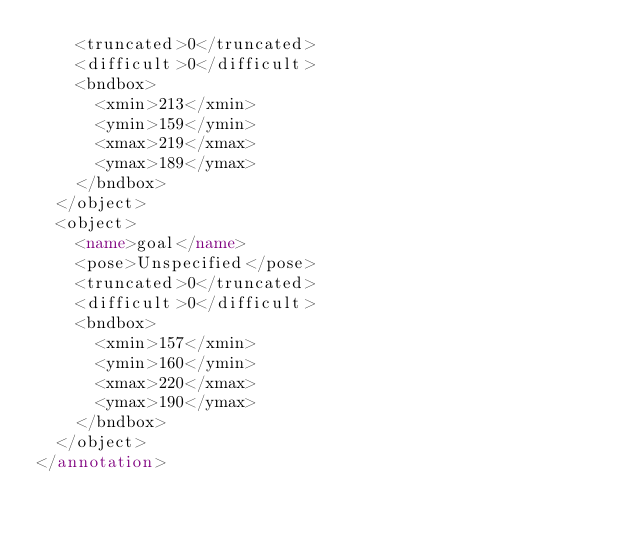Convert code to text. <code><loc_0><loc_0><loc_500><loc_500><_XML_>		<truncated>0</truncated>
		<difficult>0</difficult>
		<bndbox>
			<xmin>213</xmin>
			<ymin>159</ymin>
			<xmax>219</xmax>
			<ymax>189</ymax>
		</bndbox>
	</object>
	<object>
		<name>goal</name>
		<pose>Unspecified</pose>
		<truncated>0</truncated>
		<difficult>0</difficult>
		<bndbox>
			<xmin>157</xmin>
			<ymin>160</ymin>
			<xmax>220</xmax>
			<ymax>190</ymax>
		</bndbox>
	</object>
</annotation>
</code> 